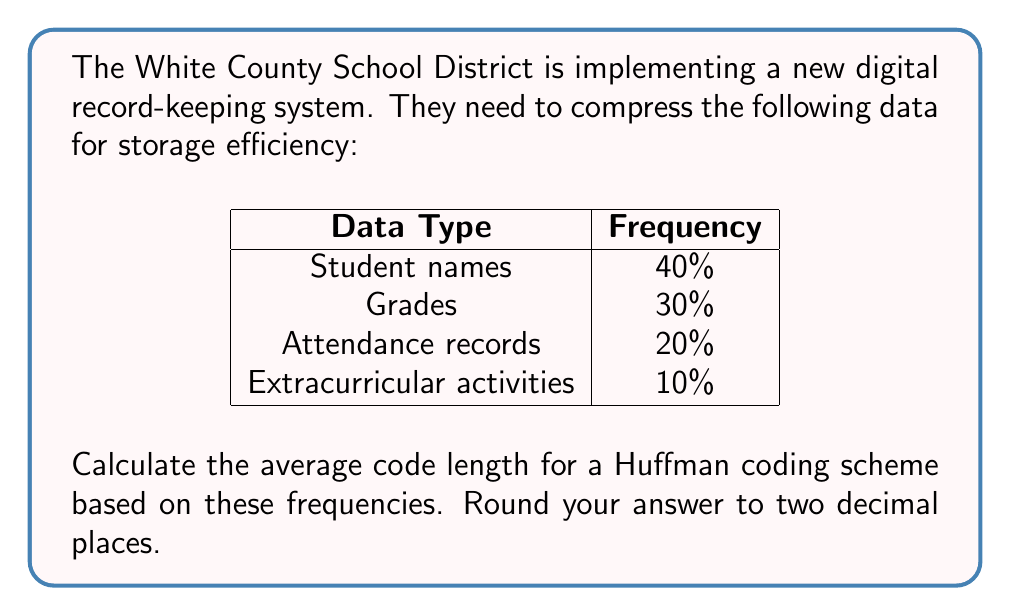Solve this math problem. Let's approach this step-by-step using Huffman coding:

1) First, we need to order the symbols by frequency:
   - Student names: 40%
   - Grades: 30%
   - Attendance records: 20%
   - Extracurricular activities: 10%

2) Now, we'll build the Huffman tree:

   [asy]
   unitsize(30);
   pair A=(0,0), B=(1,0), C=(2,0), D=(3,0), E=(1.5,1), F=(0.5,2), G=(0,3);
   dot(A); dot(B); dot(C); dot(D); dot(E); dot(F); dot(G);
   draw(A--F--B);
   draw(C--E--D);
   draw(E--G--F);
   label("10%", A, S);
   label("20%", B, S);
   label("30%", C, S);
   label("40%", D, S);
   label("30%", E, NE);
   label("60%", F, NW);
   label("100%", G, N);
   [/asy]

3) From this tree, we can determine the code lengths:
   - Student names (40%): 1 bit
   - Grades (30%): 2 bits
   - Attendance records (20%): 3 bits
   - Extracurricular activities (10%): 3 bits

4) To calculate the average code length, we multiply each probability by its code length and sum:

   $$ L_{avg} = (0.40 \times 1) + (0.30 \times 2) + (0.20 \times 3) + (0.10 \times 3) $$

5) Calculating:
   $$ L_{avg} = 0.40 + 0.60 + 0.60 + 0.30 = 1.90 $$

Therefore, the average code length is 1.90 bits.
Answer: 1.90 bits 